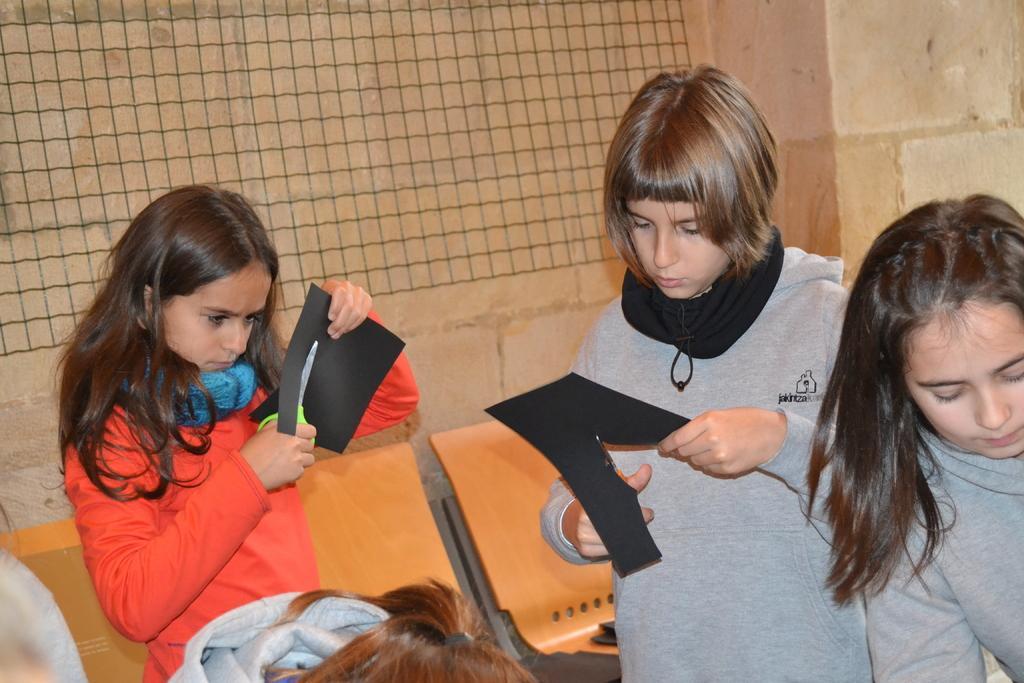Please provide a concise description of this image. In this image I can see the group of people with different color dresses. I can see two people are holding the black color papers and the scissors. In the background I can see the wall. 